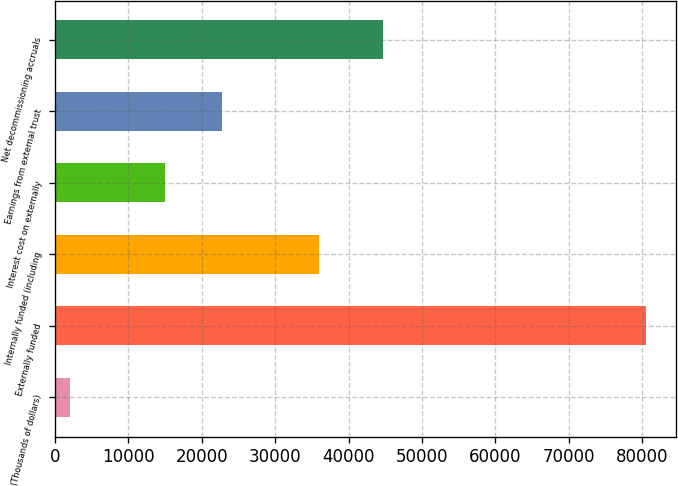Convert chart to OTSL. <chart><loc_0><loc_0><loc_500><loc_500><bar_chart><fcel>(Thousands of dollars)<fcel>Externally funded<fcel>Internally funded (including<fcel>Interest cost on externally<fcel>Earnings from external trust<fcel>Net decommissioning accruals<nl><fcel>2003<fcel>80582<fcel>35906<fcel>14952<fcel>22809.9<fcel>44676<nl></chart> 